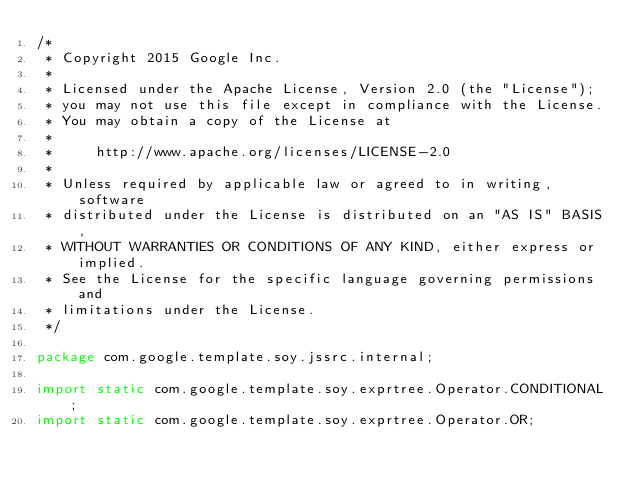Convert code to text. <code><loc_0><loc_0><loc_500><loc_500><_Java_>/*
 * Copyright 2015 Google Inc.
 *
 * Licensed under the Apache License, Version 2.0 (the "License");
 * you may not use this file except in compliance with the License.
 * You may obtain a copy of the License at
 *
 *     http://www.apache.org/licenses/LICENSE-2.0
 *
 * Unless required by applicable law or agreed to in writing, software
 * distributed under the License is distributed on an "AS IS" BASIS,
 * WITHOUT WARRANTIES OR CONDITIONS OF ANY KIND, either express or implied.
 * See the License for the specific language governing permissions and
 * limitations under the License.
 */

package com.google.template.soy.jssrc.internal;

import static com.google.template.soy.exprtree.Operator.CONDITIONAL;
import static com.google.template.soy.exprtree.Operator.OR;</code> 